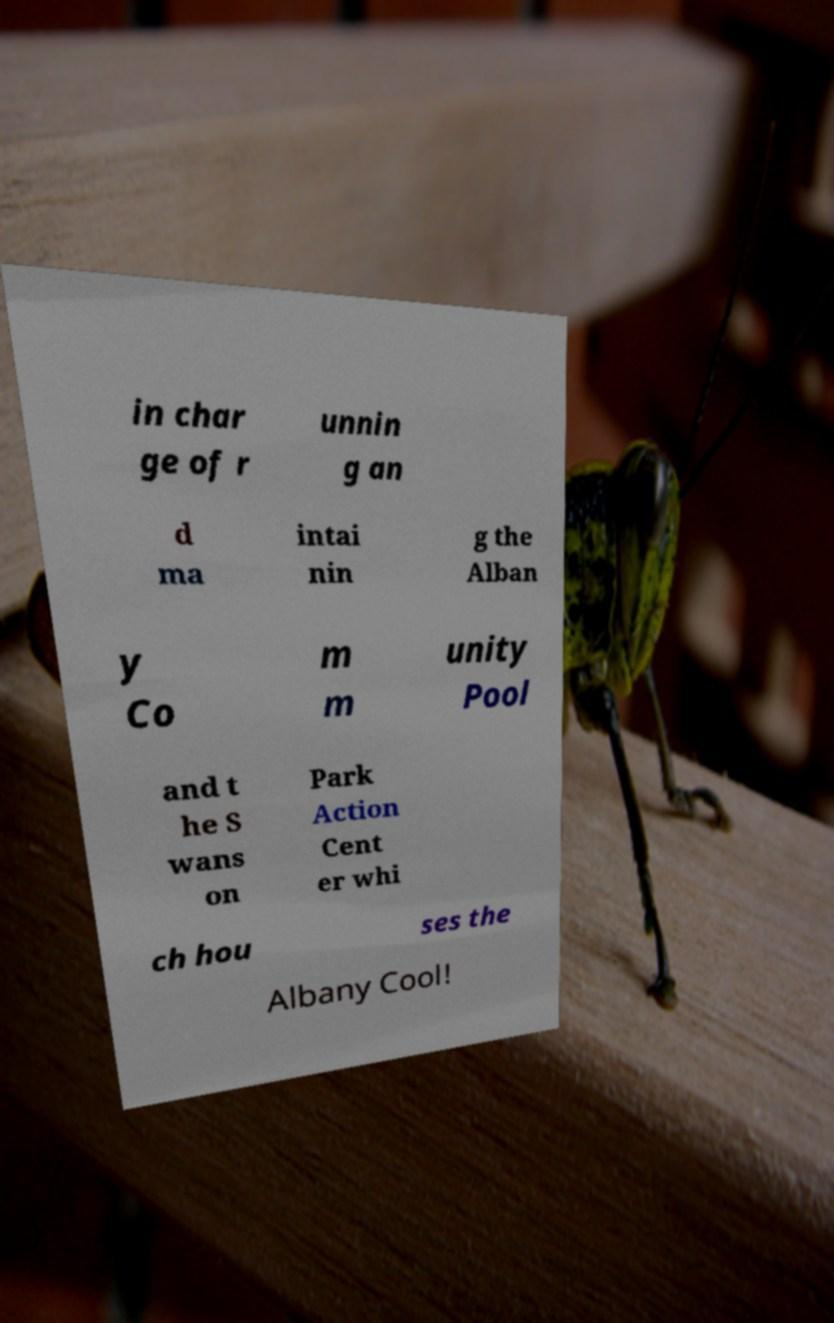I need the written content from this picture converted into text. Can you do that? in char ge of r unnin g an d ma intai nin g the Alban y Co m m unity Pool and t he S wans on Park Action Cent er whi ch hou ses the Albany Cool! 